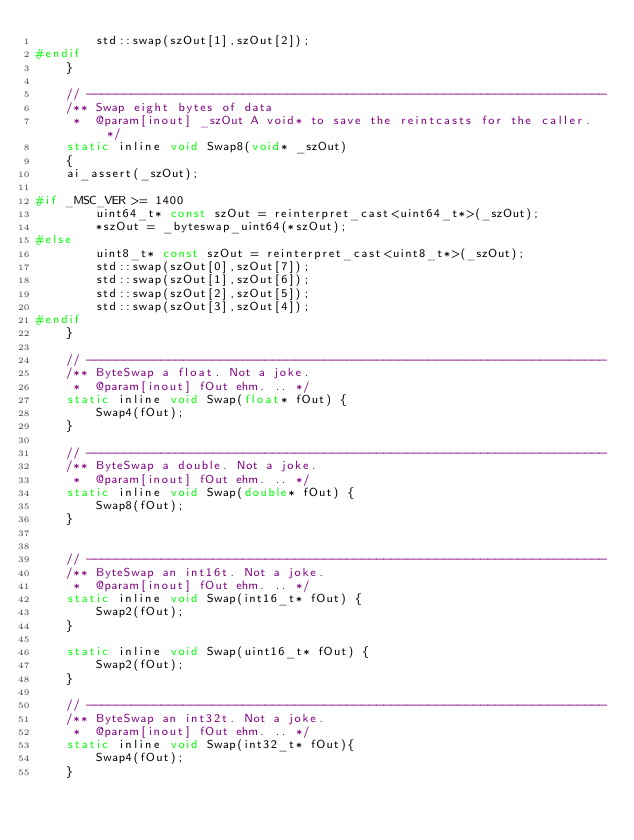Convert code to text. <code><loc_0><loc_0><loc_500><loc_500><_C_>        std::swap(szOut[1],szOut[2]);
#endif
    }

    // ----------------------------------------------------------------------
    /** Swap eight bytes of data
     *  @param[inout] _szOut A void* to save the reintcasts for the caller. */
    static inline void Swap8(void* _szOut)
    {
    ai_assert(_szOut);

#if _MSC_VER >= 1400
        uint64_t* const szOut = reinterpret_cast<uint64_t*>(_szOut);
        *szOut = _byteswap_uint64(*szOut);
#else
        uint8_t* const szOut = reinterpret_cast<uint8_t*>(_szOut);
        std::swap(szOut[0],szOut[7]);
        std::swap(szOut[1],szOut[6]);
        std::swap(szOut[2],szOut[5]);
        std::swap(szOut[3],szOut[4]);
#endif
    }

    // ----------------------------------------------------------------------
    /** ByteSwap a float. Not a joke.
     *  @param[inout] fOut ehm. .. */
    static inline void Swap(float* fOut) {
        Swap4(fOut);
    }

    // ----------------------------------------------------------------------
    /** ByteSwap a double. Not a joke.
     *  @param[inout] fOut ehm. .. */
    static inline void Swap(double* fOut) {
        Swap8(fOut);
    }


    // ----------------------------------------------------------------------
    /** ByteSwap an int16t. Not a joke.
     *  @param[inout] fOut ehm. .. */
    static inline void Swap(int16_t* fOut) {
        Swap2(fOut);
    }

    static inline void Swap(uint16_t* fOut) {
        Swap2(fOut);
    }

    // ----------------------------------------------------------------------
    /** ByteSwap an int32t. Not a joke.
     *  @param[inout] fOut ehm. .. */
    static inline void Swap(int32_t* fOut){
        Swap4(fOut);
    }
</code> 